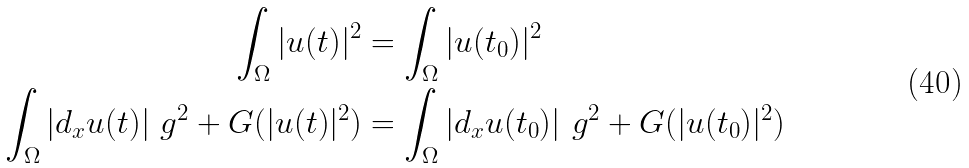Convert formula to latex. <formula><loc_0><loc_0><loc_500><loc_500>\int _ { \Omega } | u ( t ) | ^ { 2 } & = \int _ { \Omega } | u ( t _ { 0 } ) | ^ { 2 } \\ \int _ { \Omega } | d _ { x } u ( t ) | _ { \ } g ^ { 2 } + G ( | u ( t ) | ^ { 2 } ) & = \int _ { \Omega } | d _ { x } u ( t _ { 0 } ) | _ { \ } g ^ { 2 } + G ( | u ( t _ { 0 } ) | ^ { 2 } )</formula> 